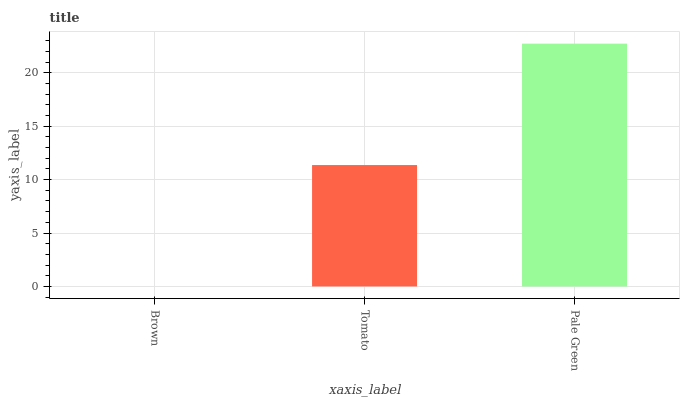Is Brown the minimum?
Answer yes or no. Yes. Is Pale Green the maximum?
Answer yes or no. Yes. Is Tomato the minimum?
Answer yes or no. No. Is Tomato the maximum?
Answer yes or no. No. Is Tomato greater than Brown?
Answer yes or no. Yes. Is Brown less than Tomato?
Answer yes or no. Yes. Is Brown greater than Tomato?
Answer yes or no. No. Is Tomato less than Brown?
Answer yes or no. No. Is Tomato the high median?
Answer yes or no. Yes. Is Tomato the low median?
Answer yes or no. Yes. Is Pale Green the high median?
Answer yes or no. No. Is Brown the low median?
Answer yes or no. No. 